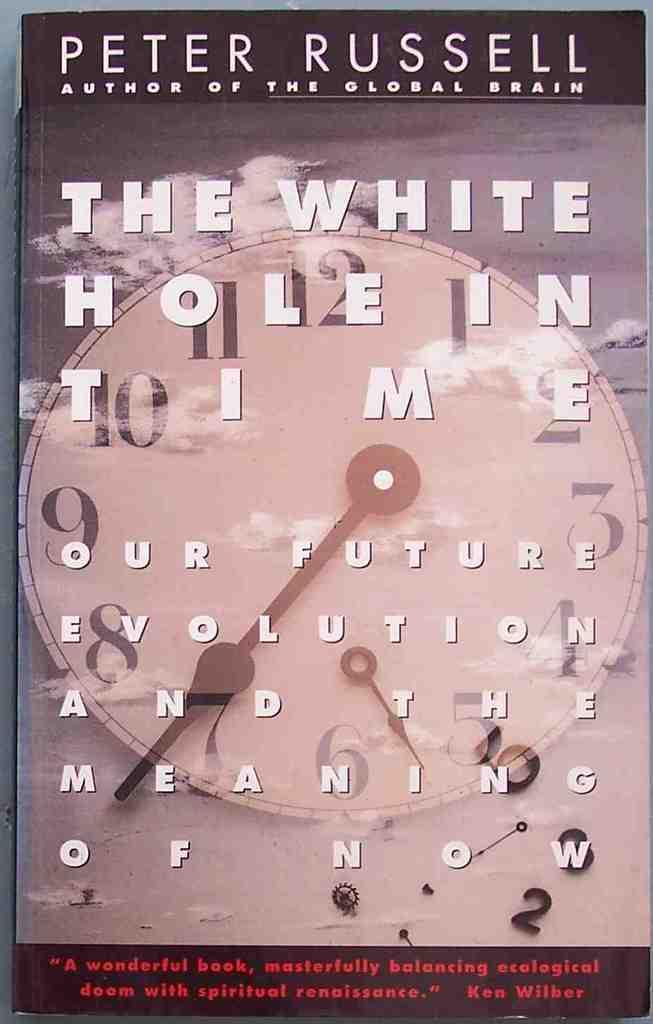What object is present in the image that people read? There is a book in the image that people read. What part of the book is visible in the image? The book's front page is visible in the image. What can be seen on the front page of the book? There is printed text on the front page of the book. What time-telling device is present in the image? There is a clock in the image. What part of the natural environment is visible in the image? The sky is visible in the image. How many beds are visible in the image? There are no beds present in the image. What type of bear can be seen interacting with the book in the image? There is no bear present in the image; only the book, clock, and sky are visible. 